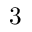Convert formula to latex. <formula><loc_0><loc_0><loc_500><loc_500>3</formula> 